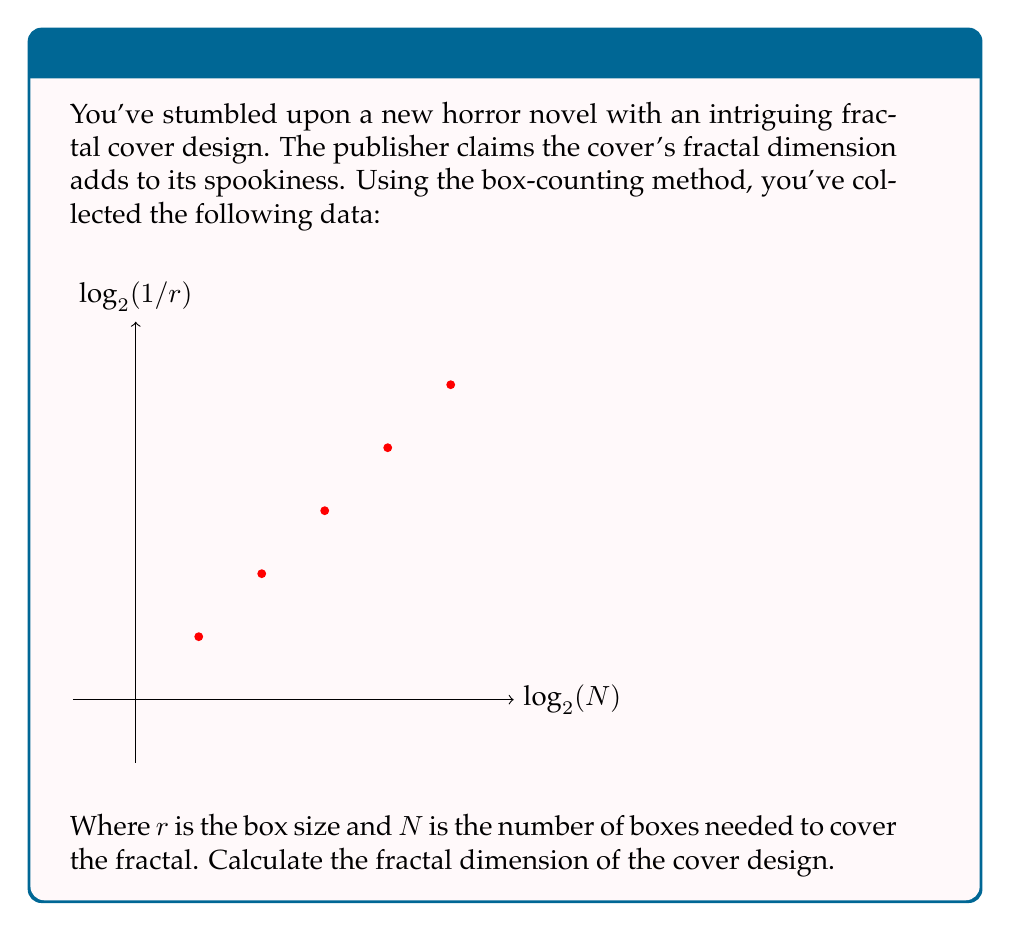Can you solve this math problem? To calculate the fractal dimension using the box-counting method, we need to find the slope of the line in the log-log plot of $N$ vs. $1/r$.

1) The fractal dimension $D$ is given by:
   $$D = -\lim_{r \to 0} \frac{\log N(r)}{\log r}$$

2) In practice, we estimate this by finding the slope of the best-fit line through our data points.

3) We can use the formula for the slope of a line:
   $$m = \frac{n\sum xy - \sum x \sum y}{n\sum x^2 - (\sum x)^2}$$
   
   Where $x = \log_2(1/r)$ and $y = \log_2(N)$

4) From the graph, we can extract the following data points:
   $(1,1)$, $(2,4)$, $(3,9)$, $(4,16)$, $(5,25)$

5) Calculate the sums:
   $\sum x = 1 + 2 + 3 + 4 + 5 = 15$
   $\sum y = 1 + 2 + 3 + 4 + 5 = 15$
   $\sum xy = 1 + 4 + 9 + 16 + 25 = 55$
   $\sum x^2 = 1 + 4 + 9 + 16 + 25 = 55$

6) Apply the slope formula:
   $$m = \frac{5(55) - 15(15)}{5(55) - 15^2} = \frac{275 - 225}{275 - 225} = 2$$

7) The slope of the line is 2, which corresponds to the fractal dimension.
Answer: $D = 2$ 